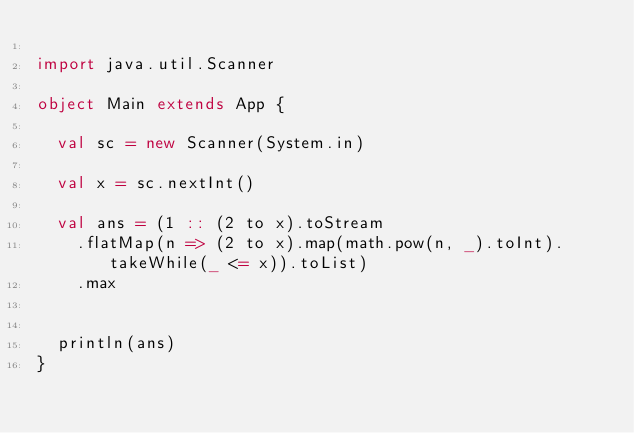<code> <loc_0><loc_0><loc_500><loc_500><_Scala_>
import java.util.Scanner

object Main extends App {

  val sc = new Scanner(System.in)

  val x = sc.nextInt()

  val ans = (1 :: (2 to x).toStream
    .flatMap(n => (2 to x).map(math.pow(n, _).toInt).takeWhile(_ <= x)).toList)
    .max


  println(ans)
}
</code> 